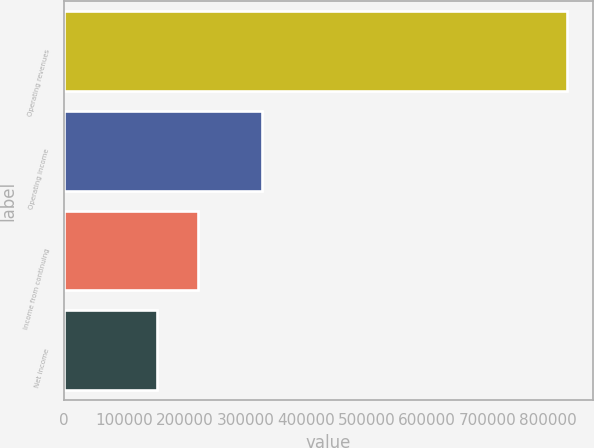Convert chart to OTSL. <chart><loc_0><loc_0><loc_500><loc_500><bar_chart><fcel>Operating revenues<fcel>Operating income<fcel>Income from continuing<fcel>Net income<nl><fcel>831815<fcel>327640<fcel>221612<fcel>153812<nl></chart> 